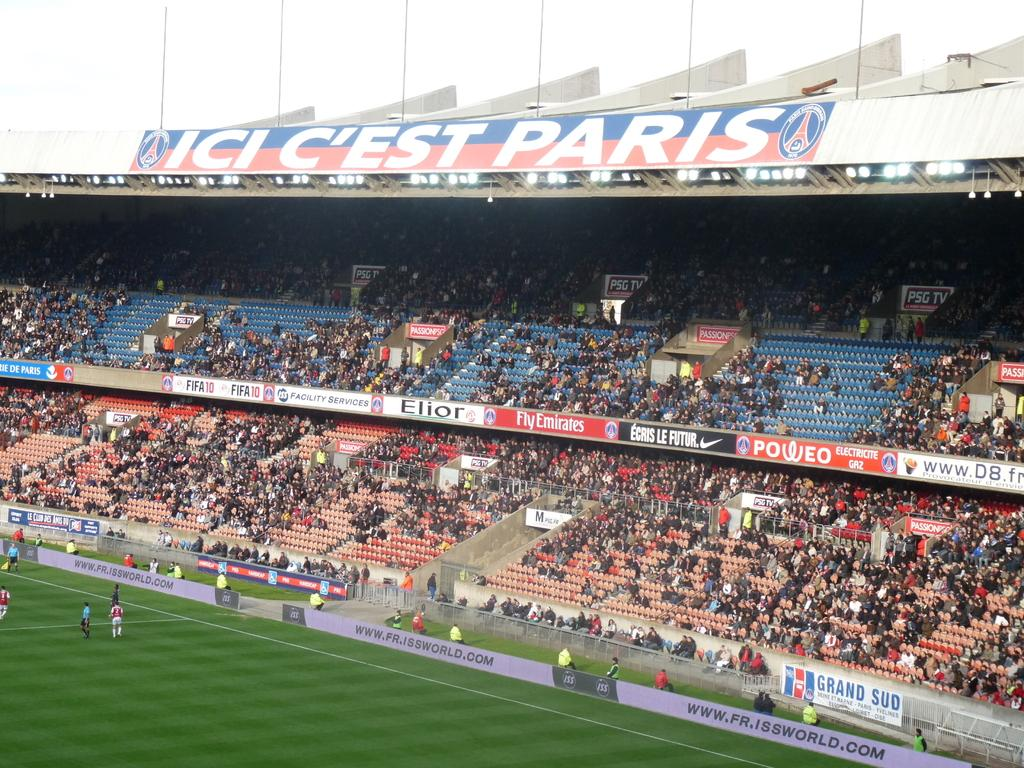What is the main location depicted in the image? There is a stadium in the image. Who can be seen in the stadium? People are present watching a match in the stadium. Are there any people outside the stadium? Yes, people are present on the ground outside the stadium. What type of income can be seen in the image? There is no reference to income in the image; it features a stadium with people watching a match. Can you tell me how many baseballs are visible in the image? There is no mention of baseball in the image; it only shows a stadium and people watching a match. 